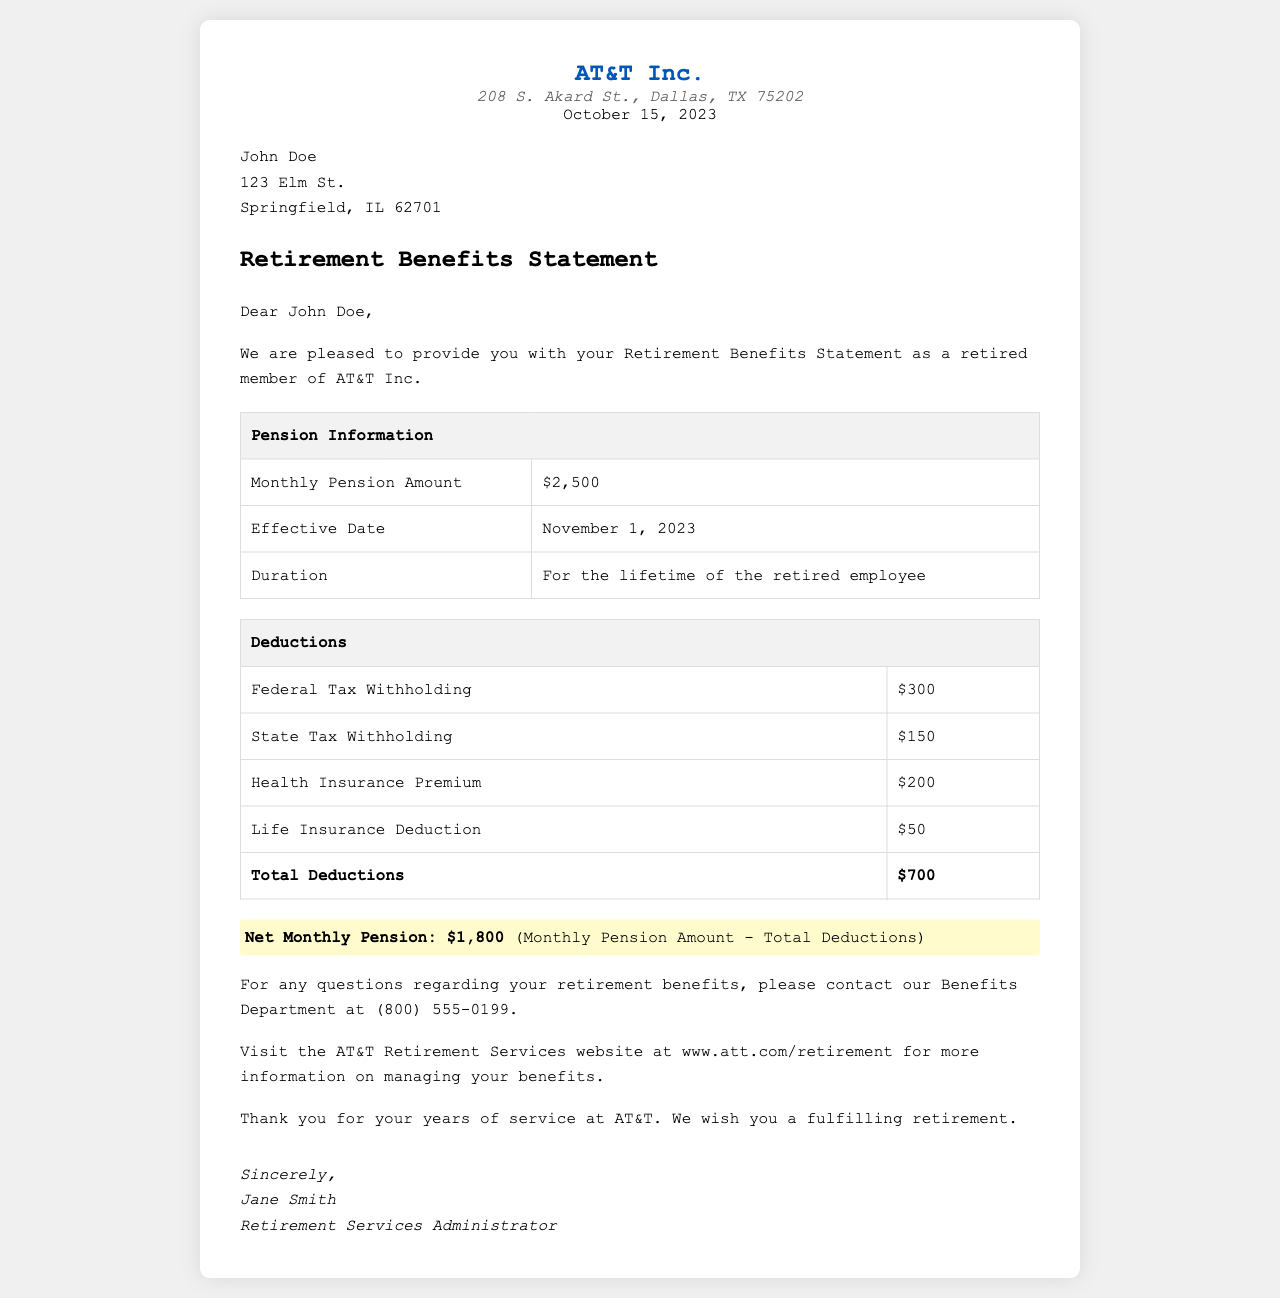What is the monthly pension amount? The monthly pension amount is clearly stated in the document.
Answer: $2,500 What is the effective date of the pension? The effective date is provided under Pension Information.
Answer: November 1, 2023 What is the total amount of deductions? The total deductions are summarized at the end of the Deductions table.
Answer: $700 Who is the Retirement Services Administrator? The name of the Retirement Services Administrator is mentioned in the signature section.
Answer: Jane Smith What is the net monthly pension amount? The net monthly pension amount is highlighted in the document.
Answer: $1,800 How long is the pension provided for? The duration of the pension is explained under Pension Information.
Answer: For the lifetime of the retired employee What is the address of AT&T Inc.? The address is provided in the header section of the document.
Answer: 208 S. Akard St., Dallas, TX 75202 What is the state tax withholding amount? The state tax withholding is detailed in the Deductions table.
Answer: $150 What is the contact number for the Benefits Department? The contact number is provided in the section about questions regarding retirement benefits.
Answer: (800) 555-0199 